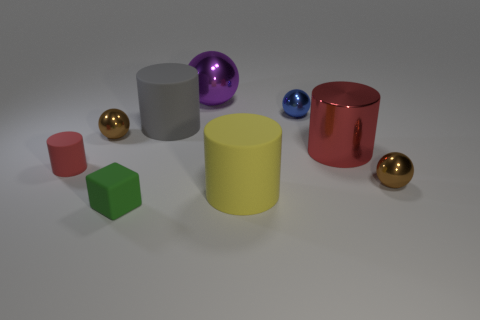Subtract 1 balls. How many balls are left? 3 Subtract all green cylinders. Subtract all brown balls. How many cylinders are left? 4 Add 1 blue shiny things. How many objects exist? 10 Subtract all cylinders. How many objects are left? 5 Add 5 purple metal spheres. How many purple metal spheres are left? 6 Add 4 small yellow metal cylinders. How many small yellow metal cylinders exist? 4 Subtract 1 red cylinders. How many objects are left? 8 Subtract all tiny gray matte cylinders. Subtract all big rubber cylinders. How many objects are left? 7 